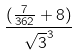Convert formula to latex. <formula><loc_0><loc_0><loc_500><loc_500>\frac { ( \frac { 7 } { 3 6 2 } + 8 ) } { \sqrt { 3 } ^ { 3 } }</formula> 